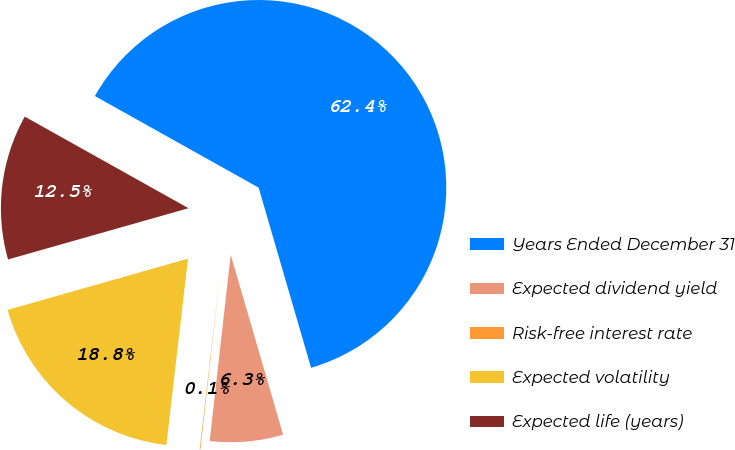<chart> <loc_0><loc_0><loc_500><loc_500><pie_chart><fcel>Years Ended December 31<fcel>Expected dividend yield<fcel>Risk-free interest rate<fcel>Expected volatility<fcel>Expected life (years)<nl><fcel>62.37%<fcel>6.29%<fcel>0.06%<fcel>18.75%<fcel>12.52%<nl></chart> 